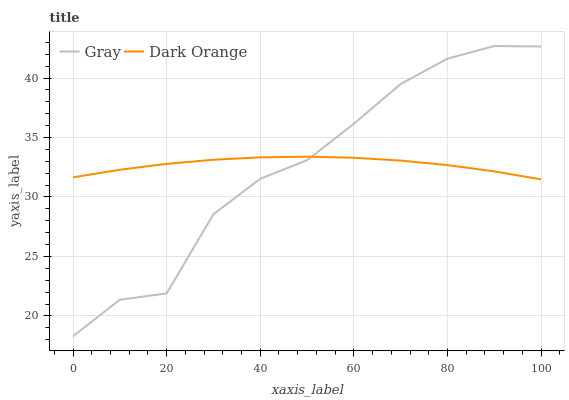Does Dark Orange have the minimum area under the curve?
Answer yes or no. No. Is Dark Orange the roughest?
Answer yes or no. No. Does Dark Orange have the lowest value?
Answer yes or no. No. Does Dark Orange have the highest value?
Answer yes or no. No. 